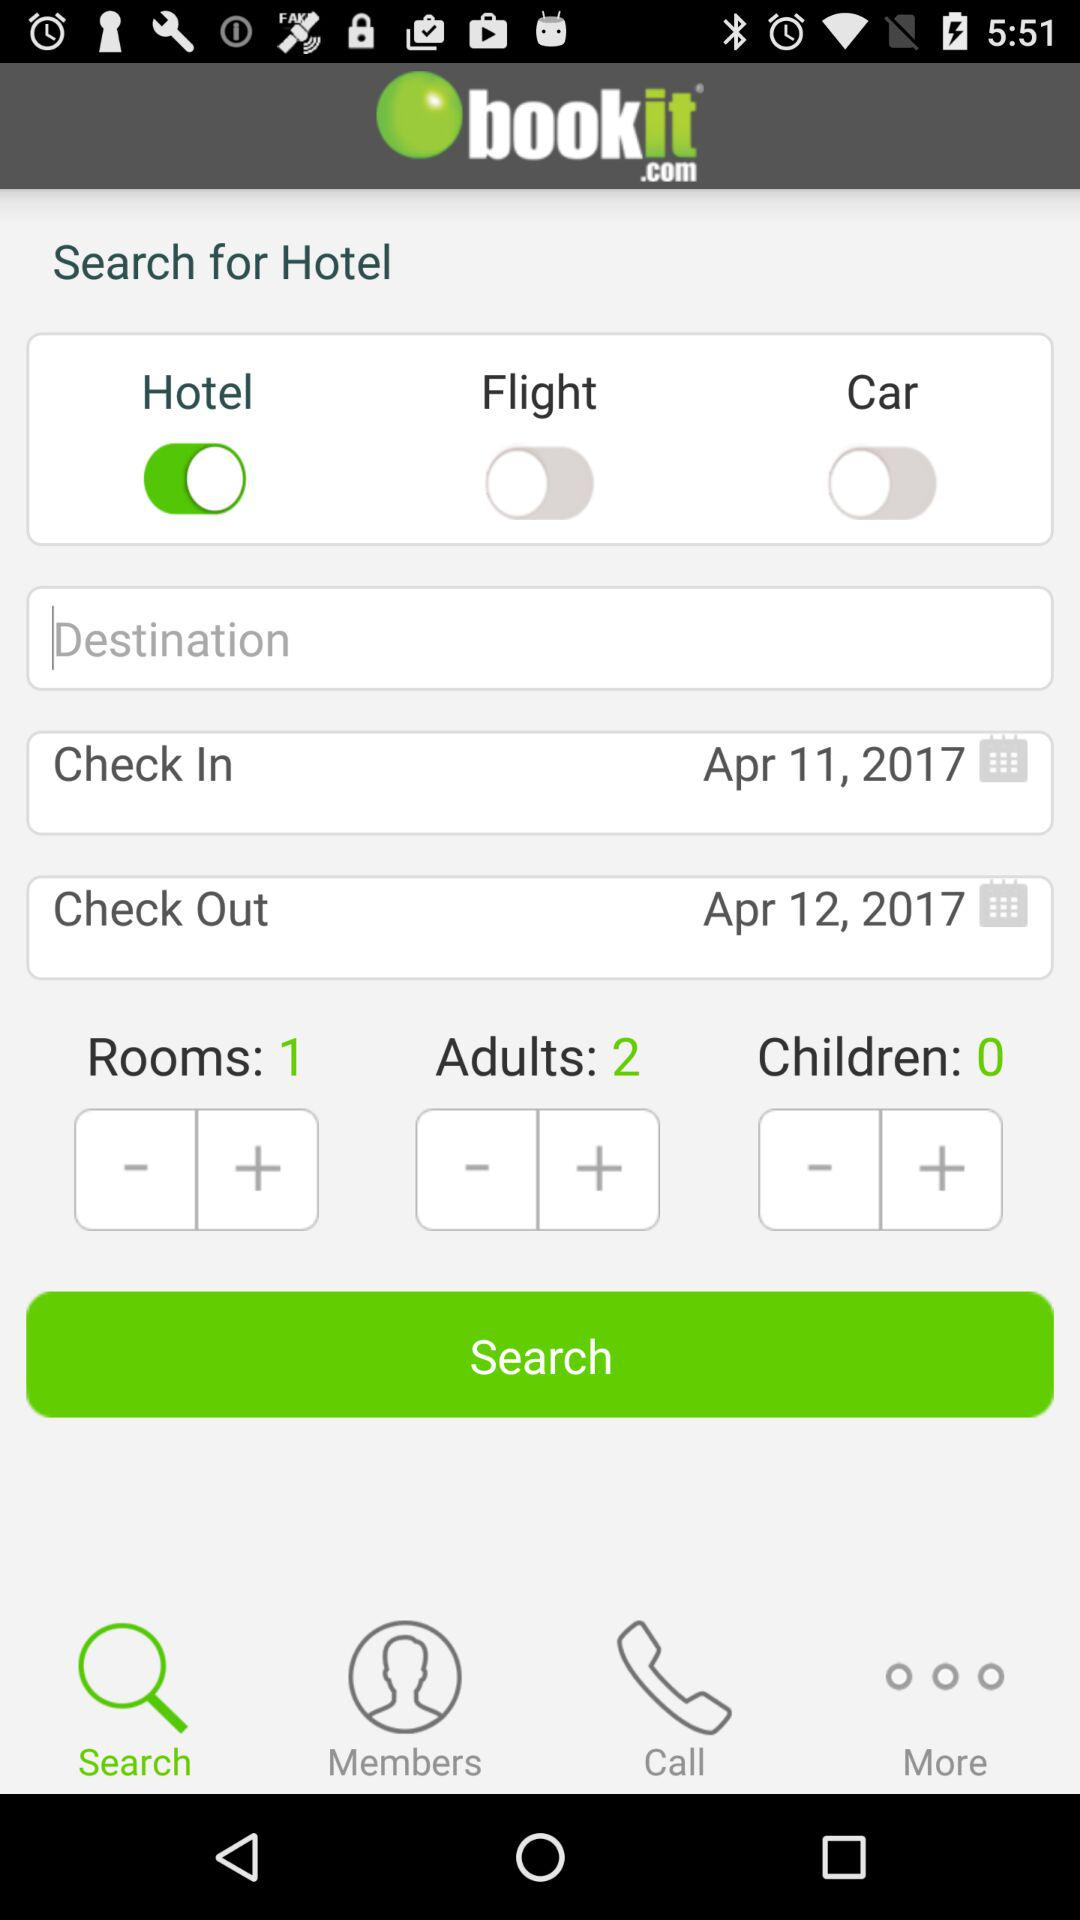How many rooms have been selected? There has been a selection of 1 room. 